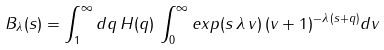Convert formula to latex. <formula><loc_0><loc_0><loc_500><loc_500>B _ { \lambda } ( s ) = \int _ { 1 } ^ { \infty } d q \, H ( q ) \, \int _ { 0 } ^ { \infty } e x p ( s \, \lambda \, v ) \, ( v + 1 ) ^ { - \lambda \, ( s + q ) } d v</formula> 